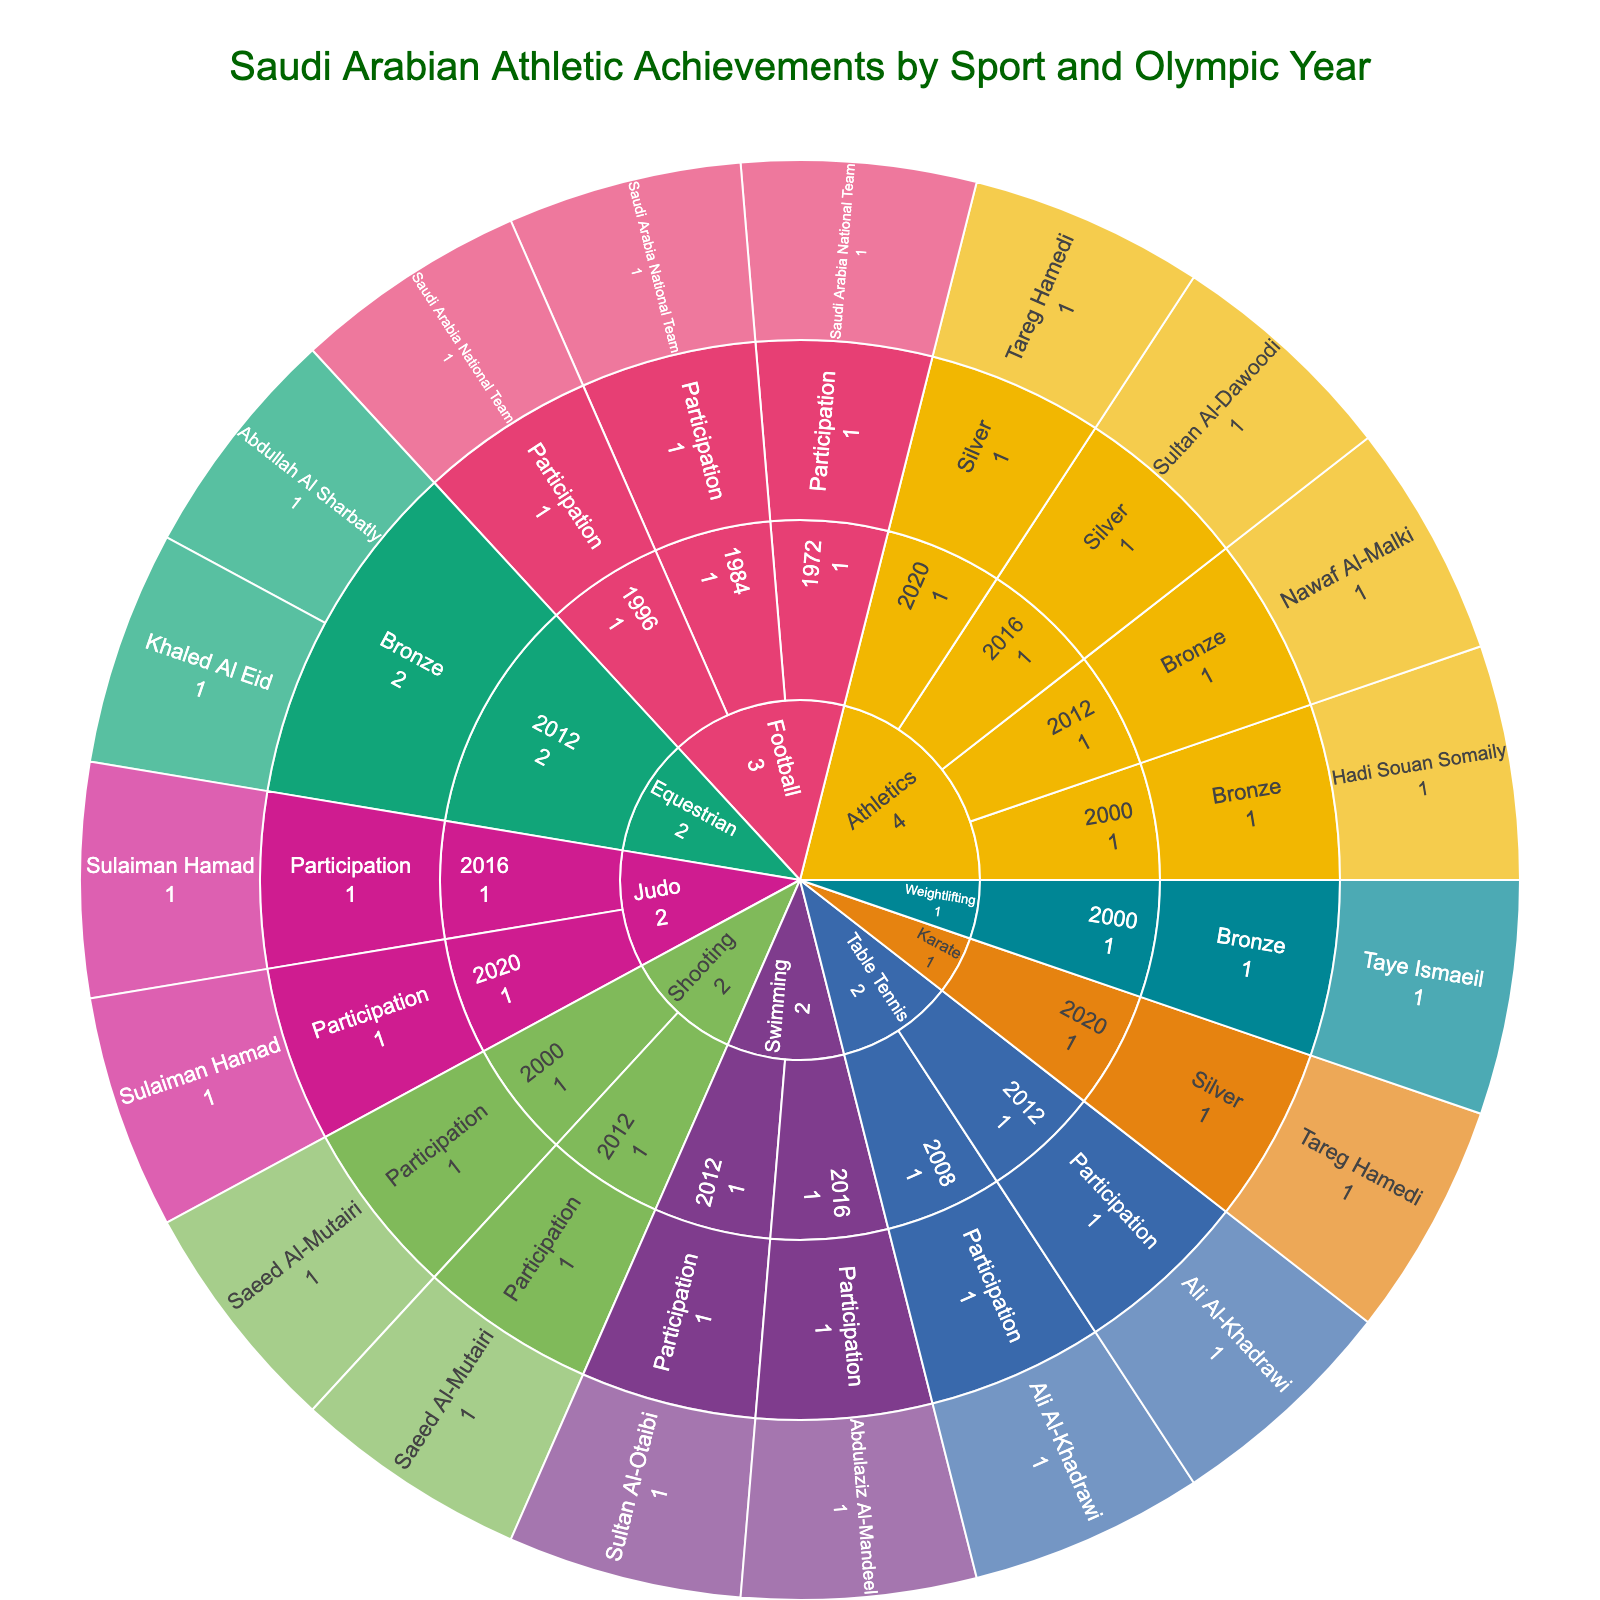How many sports are represented in the figure? The figure uses different colors to represent each sport, and each sport name is visible in the center ring of the sunburst plot. Count the distinct sport names.
Answer: 8 Which sport has the most Olympic years participation? Look at the sunburst plot and identify the sport with the most outer segments (years) attached.
Answer: Football Who is the only athlete to appear in multiple years and multiple sports? Look at the names on the outer ring and see who appears in multiple sports. This requires identifying names on different sport segments.
Answer: Tareg Hamedi In which year did Saudi Arabia achieve the most medals? Sum up the segments of the sunburst plot with medal-related labels for each year (not "Participation").
Answer: 2012 What is the total number of participation entries in all years for the sport of Shooting? Identify the segments for Shooting and count all the occurrences labeled "Participation."
Answer: 2 Which sport has the highest count of silver medals? Find the segments with silver medals for each sport and count them, then compare the counts.
Answer: Athletics How many athletes have won medals in Equestrian in 2012? Navigate to the Equestrian segment, expand to the year 2012, and count the athletes listed under the medal categories.
Answer: 2 Compare the total number of participation and medal entries for Athletics. Which is greater and by how much? Count all "Participation" entries for Athletics and all medal entries, then find the difference.
Answer: Participation is greater by 1 What is the only sport where Saudi Arabia has participation but no medals? Look for sports that have segments labeled "Participation" but no segments under "medal" categories.
Answer: Table Tennis Which sport has the most diverse medal distribution (Gold, Silver, Bronze)? Check each sport’s medals and identify the one with the most different types of medals (Gold, Silver, Bronze).
Answer: Athletics 